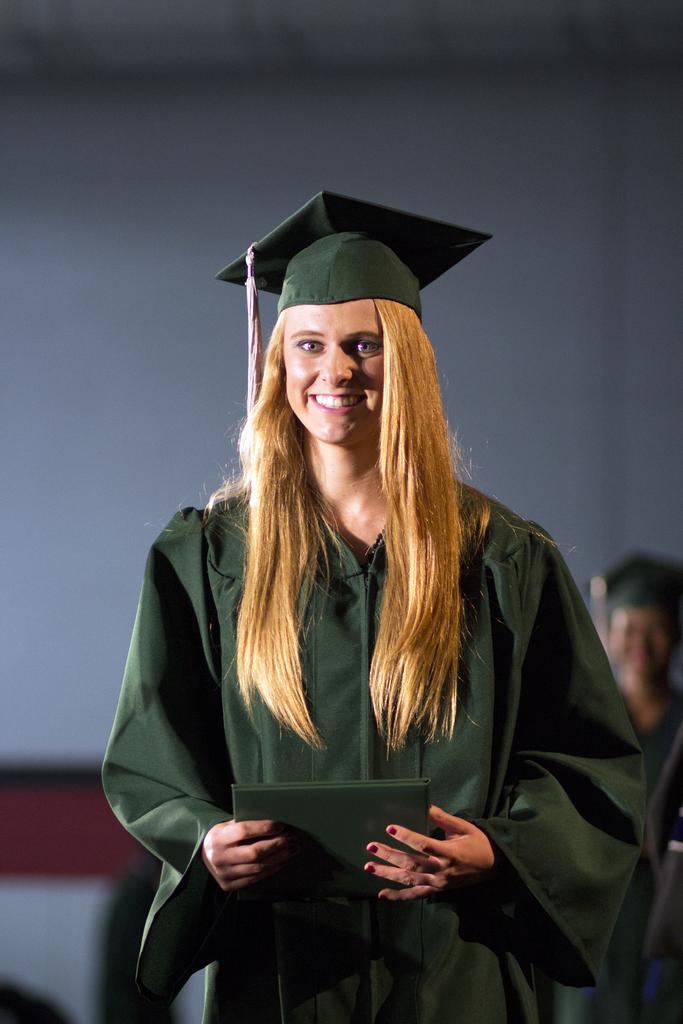In one or two sentences, can you explain what this image depicts? In this image we can see one woman with an academic dress. And she is holding one book. 